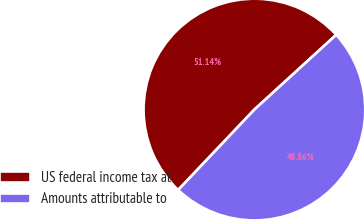Convert chart. <chart><loc_0><loc_0><loc_500><loc_500><pie_chart><fcel>US federal income tax at<fcel>Amounts attributable to<nl><fcel>51.14%<fcel>48.86%<nl></chart> 